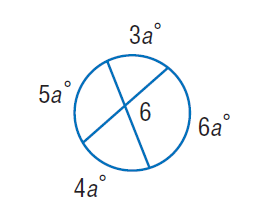Answer the mathemtical geometry problem and directly provide the correct option letter.
Question: Find \angle 6.
Choices: A: 110 B: 140 C: 150 D: 220 A 